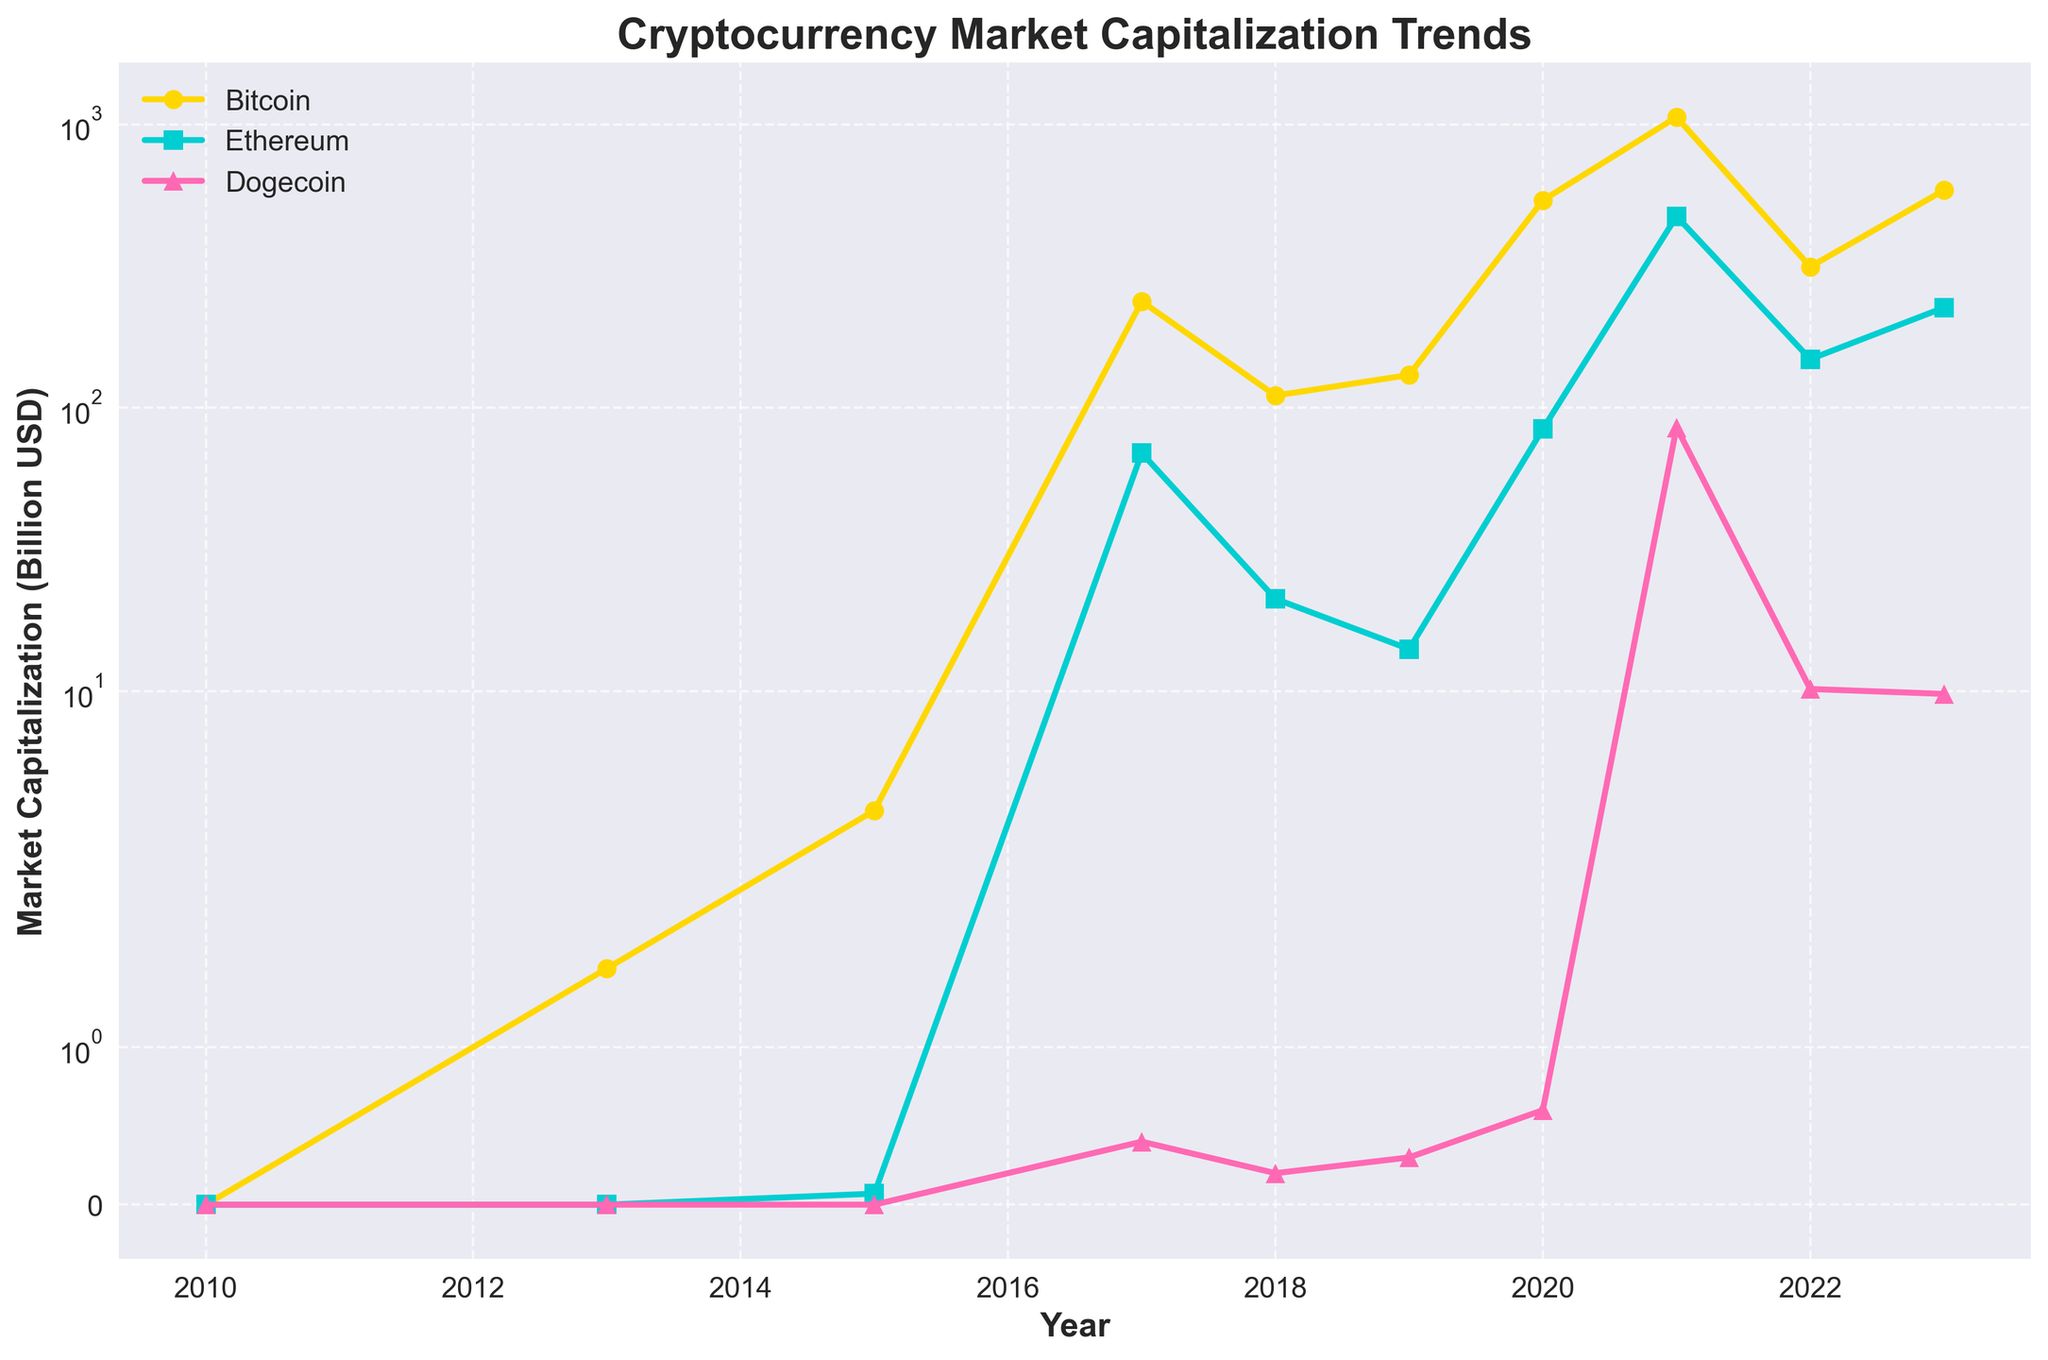What's the market capitalization trend for Bitcoin compared to Ethereum and Dogecoin in 2021? In 2021, Bitcoin has the highest peak at 1060.3 billion USD, followed by Ethereum at 473.8 billion USD, and Dogecoin at 85.3 billion USD. This indicates a significant dominance of Bitcoin over the other two cryptocurrencies this year.
Answer: Bitcoin was significantly higher than both Ethereum and Dogecoin What's the relative change in Bitcoin's market capitalization between 2020 and 2023? In 2020, Bitcoin's market capitalization was 539.7 billion USD, and it increased to 585.2 billion USD in 2023. The absolute change is 585.2-539.7 = 45.5 billion USD. To find the relative change, (45.5/539.7) * 100 ≈ 8.43%.
Answer: Approximately 8.43% increase In which year did Ethereum first surpass Dogecoin in market capitalization, and by how much? Ethereum first surpassed Dogecoin in market capitalization in 2017. Ethereum's market capitalization was 69.3 billion USD, while Dogecoin's was 0.4 billion USD. The difference is 69.3 - 0.4 = 68.9 billion USD.
Answer: In 2017, by 68.9 billion USD Did Dogecoin's market capitalization ever exceed Bitcoin's during the period shown? By observing the plot, in all the years shown, Bitcoin's market capitalization is consistently higher than Dogecoin's. There are no instances where Dogecoin exceeded Bitcoin.
Answer: No, it never did What's the average market capitalization of Ethereum from 2017 to 2023? The market capitalization values for Ethereum from 2017 to 2023 are: 69.3, 21.2, 14.1, 84.2, 473.8, 148.5, and 225.7 billion USD. Sum these values: 69.3 + 21.2 + 14.1 + 84.2 + 473.8 + 148.5 + 225.7 = 1036.8 billion USD. The average is 1036.8 / 7 ≈ 148.11 billion USD.
Answer: Approximately 148.11 billion USD Which cryptocurrency shows the greatest relative percentage drop in market capitalization between 2021 and 2022? Bitcoin drops from 1060.3 in 2021 to 314.6 in 2022, a decrease of (1060.3-314.6)/1060.3 ≈ 70.33%. Ethereum drops from 473.8 to 148.5, a decrease of (473.8-148.5)/473.8 ≈ 68.67%. Dogecoin drops from 85.3 to 10.2, a decrease of (85.3-10.2)/85.3 ≈ 88.04%. Dogecoin has the greatest relative percentage drop.
Answer: Dogecoin, approximately 88.04% Describe the general market capitalization trend for Dogecoin from 2015 to 2023. From 2015 to 2017, Dogecoin's market capitalization saw a moderate increase from 0.0001 to 0.4 billion USD. In 2018, it dropped to 0.2 billion USD. A slight increase occurred in the following years, peaking dramatically at 85.3 billion USD in 2021, but then dropping to 10.2 billion USD in 2022 and slightly falling to 9.8 billion USD in 2023.
Answer: Initial moderate increase, sudden peak in 2021, followed by decline In which year did Bitcoin's market capitalization experience the highest absolute increase compared to the previous year? By examining the data, the largest year-on-year increase for Bitcoin occurred between 2020 and 2021, from 539.7 to 1060.3 billion USD. The absolute increase was 1060.3 - 539.7 = 520.6 billion USD.
Answer: From 2020 to 2021, with an absolute increase of 520.6 billion USD What's the cumulative market capitalization of Bitcoin, Ethereum, and Dogecoin in 2017? In 2017, Bitcoin's market capitalization was 237.5 billion USD, Ethereum's was 69.3 billion USD, and Dogecoin's was 0.4 billion USD. The cumulative market capitalization is 237.5 + 69.3 + 0.4 = 307.2 billion USD.
Answer: 307.2 billion USD 